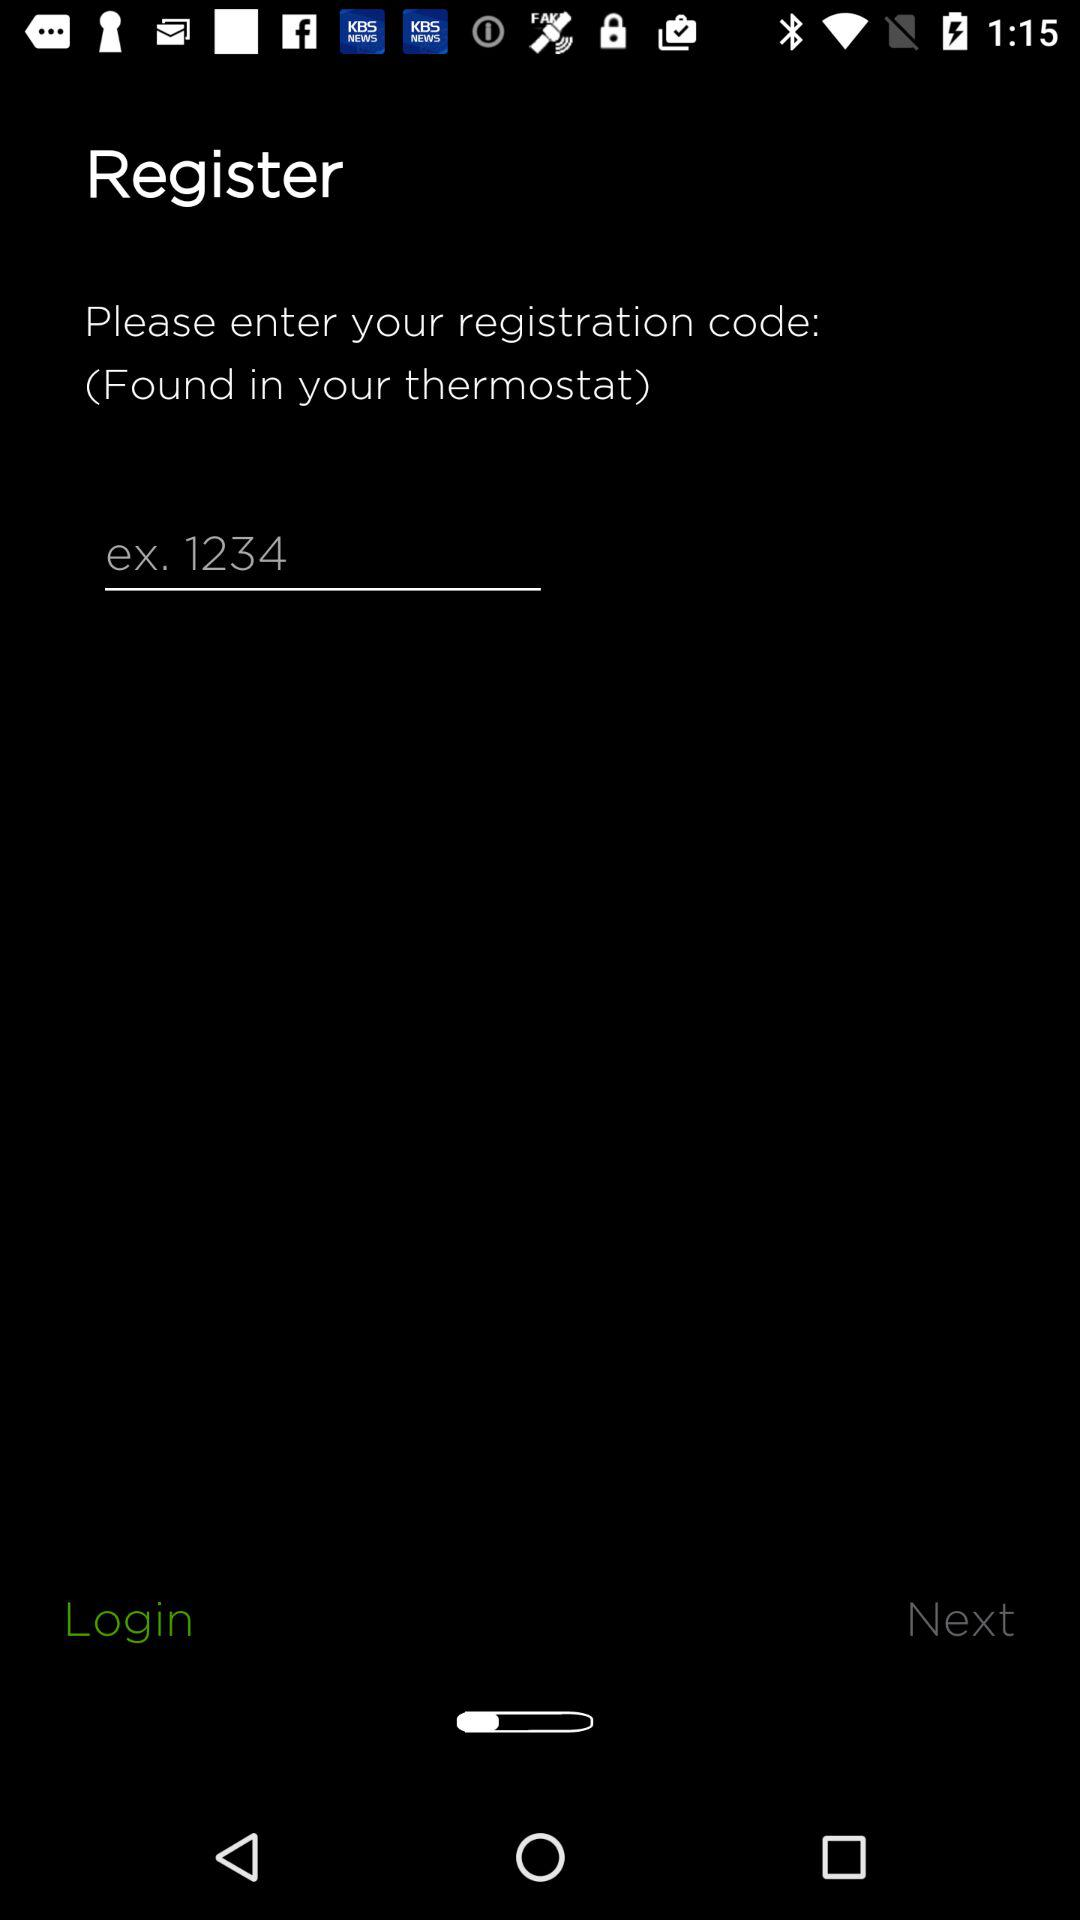Where can user find the Registration code? A user can find the registration code on the thermostat. 